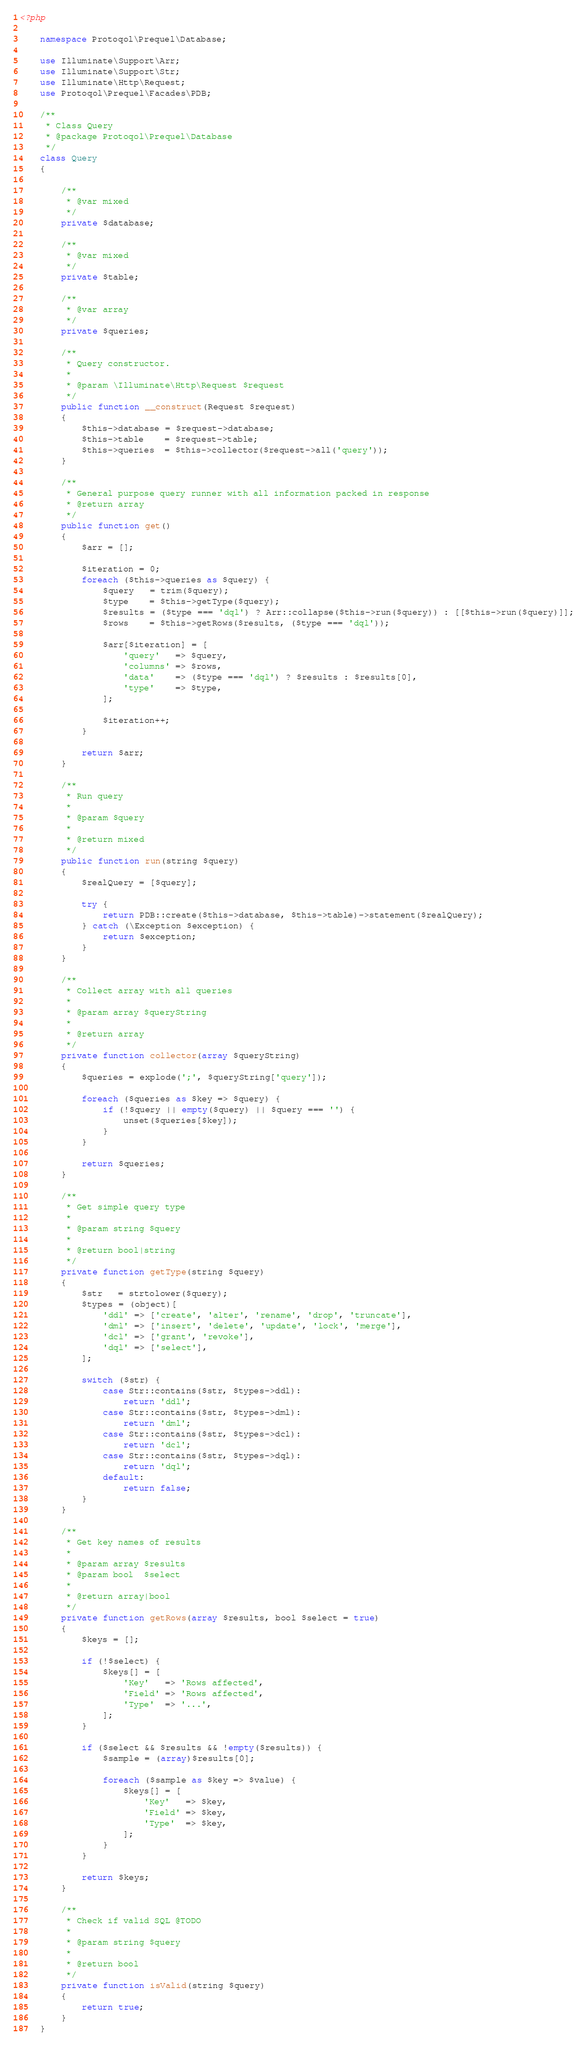Convert code to text. <code><loc_0><loc_0><loc_500><loc_500><_PHP_><?php
    
    namespace Protoqol\Prequel\Database;
    
    use Illuminate\Support\Arr;
    use Illuminate\Support\Str;
    use Illuminate\Http\Request;
    use Protoqol\Prequel\Facades\PDB;
    
    /**
     * Class Query
     * @package Protoqol\Prequel\Database
     */
    class Query
    {
        
        /**
         * @var mixed
         */
        private $database;
        
        /**
         * @var mixed
         */
        private $table;
        
        /**
         * @var array
         */
        private $queries;
        
        /**
         * Query constructor.
         *
         * @param \Illuminate\Http\Request $request
         */
        public function __construct(Request $request)
        {
            $this->database = $request->database;
            $this->table    = $request->table;
            $this->queries  = $this->collector($request->all('query'));
        }
        
        /**
         * General purpose query runner with all information packed in response
         * @return array
         */
        public function get()
        {
            $arr = [];
            
            $iteration = 0;
            foreach ($this->queries as $query) {
                $query   = trim($query);
                $type    = $this->getType($query);
                $results = ($type === 'dql') ? Arr::collapse($this->run($query)) : [[$this->run($query)]];
                $rows    = $this->getRows($results, ($type === 'dql'));
                
                $arr[$iteration] = [
                    'query'   => $query,
                    'columns' => $rows,
                    'data'    => ($type === 'dql') ? $results : $results[0],
                    'type'    => $type,
                ];
                
                $iteration++;
            }
            
            return $arr;
        }
        
        /**
         * Run query
         *
         * @param $query
         *
         * @return mixed
         */
        public function run(string $query)
        {
            $realQuery = [$query];
            
            try {
                return PDB::create($this->database, $this->table)->statement($realQuery);
            } catch (\Exception $exception) {
                return $exception;
            }
        }
        
        /**
         * Collect array with all queries
         *
         * @param array $queryString
         *
         * @return array
         */
        private function collector(array $queryString)
        {
            $queries = explode(';', $queryString['query']);
            
            foreach ($queries as $key => $query) {
                if (!$query || empty($query) || $query === '') {
                    unset($queries[$key]);
                }
            }
            
            return $queries;
        }
        
        /**
         * Get simple query type
         *
         * @param string $query
         *
         * @return bool|string
         */
        private function getType(string $query)
        {
            $str   = strtolower($query);
            $types = (object)[
                'ddl' => ['create', 'alter', 'rename', 'drop', 'truncate'],
                'dml' => ['insert', 'delete', 'update', 'lock', 'merge'],
                'dcl' => ['grant', 'revoke'],
                'dql' => ['select'],
            ];
            
            switch ($str) {
                case Str::contains($str, $types->ddl):
                    return 'ddl';
                case Str::contains($str, $types->dml):
                    return 'dml';
                case Str::contains($str, $types->dcl):
                    return 'dcl';
                case Str::contains($str, $types->dql):
                    return 'dql';
                default:
                    return false;
            }
        }
        
        /**
         * Get key names of results
         *
         * @param array $results
         * @param bool  $select
         *
         * @return array|bool
         */
        private function getRows(array $results, bool $select = true)
        {
            $keys = [];
            
            if (!$select) {
                $keys[] = [
                    'Key'   => 'Rows affected',
                    'Field' => 'Rows affected',
                    'Type'  => '...',
                ];
            }
            
            if ($select && $results && !empty($results)) {
                $sample = (array)$results[0];
                
                foreach ($sample as $key => $value) {
                    $keys[] = [
                        'Key'   => $key,
                        'Field' => $key,
                        'Type'  => $key,
                    ];
                }
            }
            
            return $keys;
        }
        
        /**
         * Check if valid SQL @TODO
         *
         * @param string $query
         *
         * @return bool
         */
        private function isValid(string $query)
        {
            return true;
        }
    }
</code> 